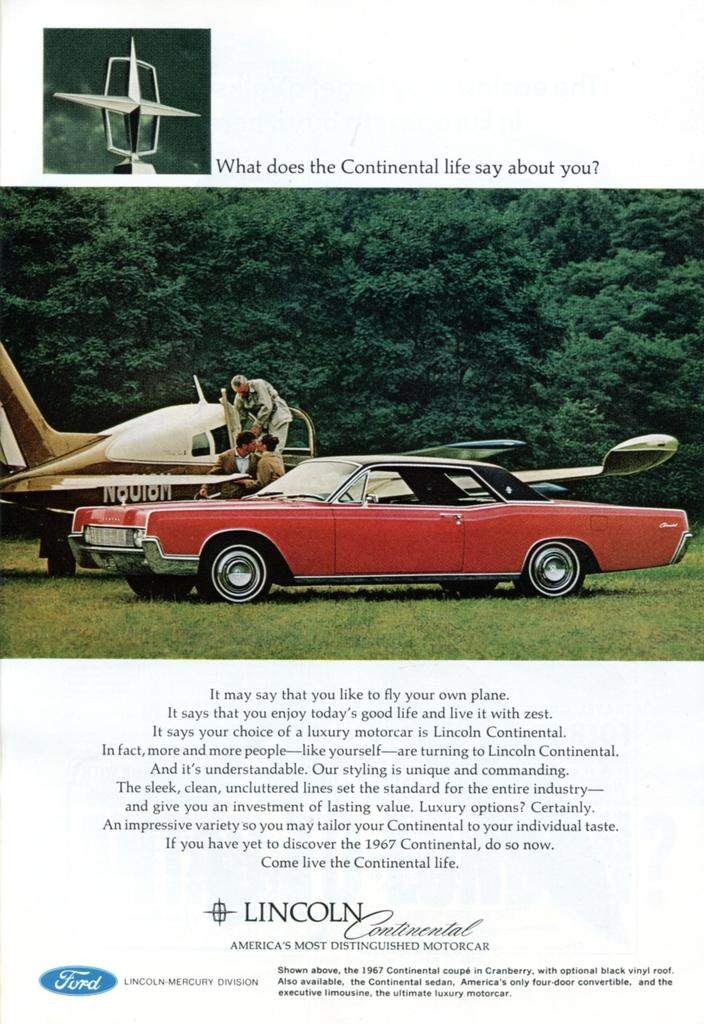What is depicted on the poster in the image? The poster contains vehicles, grass, trees, and people wearing clothes. What type of vehicles can be seen on the poster? The specific type of vehicles cannot be determined from the provided facts. What other elements are present on the poster besides the vehicles? The poster also contains grass, trees, and people wearing clothes. Is there any text on the poster? Yes, there is text in the poster. What type of pain is being experienced by the car in the image? There is no car present in the image, and therefore no pain can be attributed to any object. 